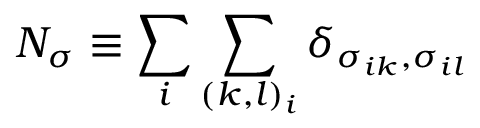Convert formula to latex. <formula><loc_0><loc_0><loc_500><loc_500>N _ { \sigma } \equiv \sum _ { i } \sum _ { ( k , l ) _ { i } } \delta _ { \sigma _ { i k } , \sigma _ { i l } }</formula> 